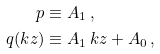<formula> <loc_0><loc_0><loc_500><loc_500>p & \equiv A _ { 1 } \, , \\ q ( k z ) & \equiv A _ { 1 } \, k z + A _ { 0 } \, ,</formula> 